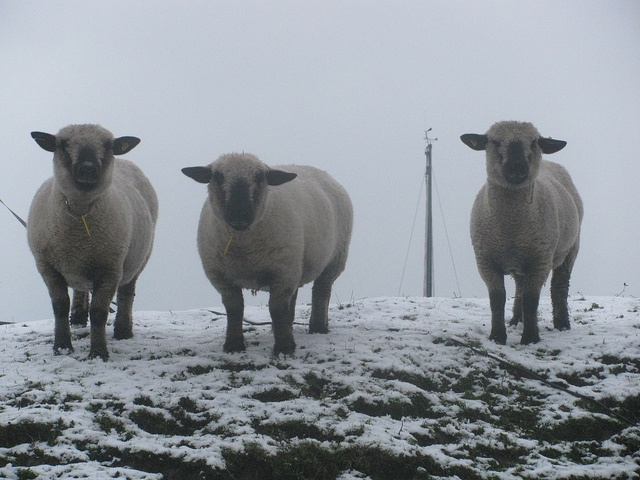Describe the objects in this image and their specific colors. I can see sheep in lightgray, gray, and black tones, sheep in lightgray, gray, and black tones, and sheep in lightgray, gray, and black tones in this image. 